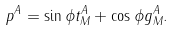Convert formula to latex. <formula><loc_0><loc_0><loc_500><loc_500>p ^ { A } = \sin \phi t ^ { A } _ { M } + \cos \phi g ^ { A } _ { M } .</formula> 